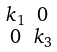<formula> <loc_0><loc_0><loc_500><loc_500>\begin{smallmatrix} k _ { 1 } & 0 \\ 0 & k _ { 3 } \end{smallmatrix}</formula> 